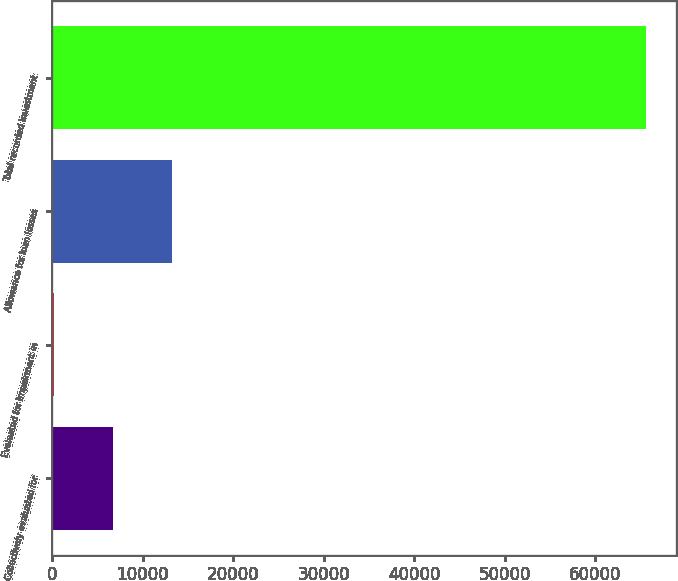<chart> <loc_0><loc_0><loc_500><loc_500><bar_chart><fcel>Collectively evaluated for<fcel>Evaluated for impairment in<fcel>Allowance for loan losses<fcel>Total recorded investment<nl><fcel>6756.7<fcel>216<fcel>13297.4<fcel>65623<nl></chart> 